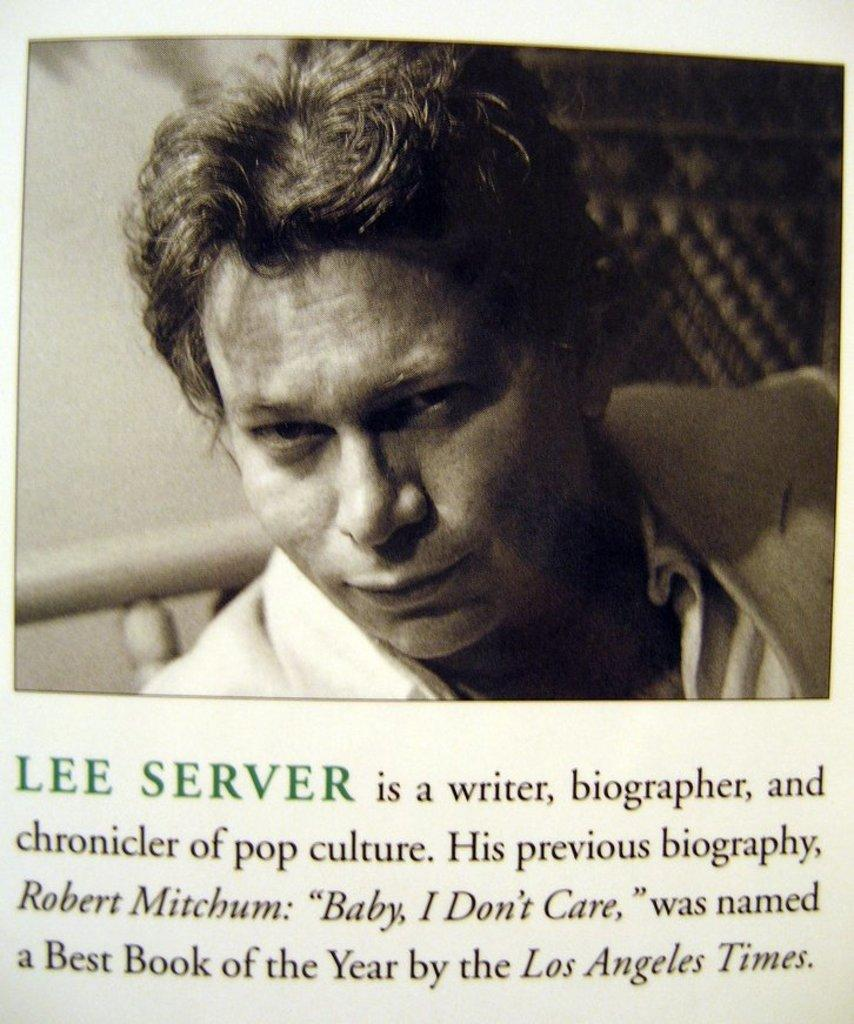Who or what is the main subject in the image? There is a person in the image. What can be seen on the person's face? The person's face is visible in the image. What is the person wearing? The person is wearing a white dress. What else is present in the image besides the person? There is a paper with writing on it in the image. What type of club can be seen in the person's hand in the image? There is no club present in the person's hand or in the image. 